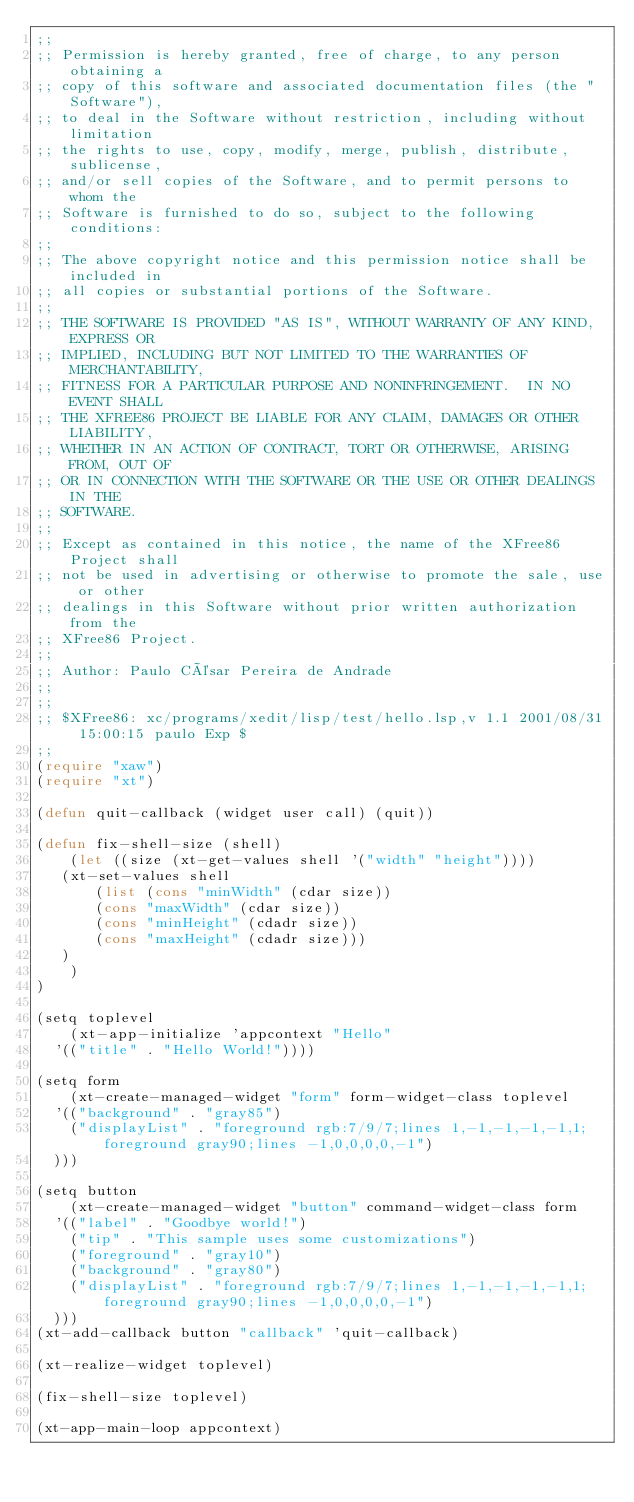Convert code to text. <code><loc_0><loc_0><loc_500><loc_500><_Lisp_>;;
;; Permission is hereby granted, free of charge, to any person obtaining a
;; copy of this software and associated documentation files (the "Software"),
;; to deal in the Software without restriction, including without limitation
;; the rights to use, copy, modify, merge, publish, distribute, sublicense,
;; and/or sell copies of the Software, and to permit persons to whom the
;; Software is furnished to do so, subject to the following conditions:
;;
;; The above copyright notice and this permission notice shall be included in
;; all copies or substantial portions of the Software.
;;  
;; THE SOFTWARE IS PROVIDED "AS IS", WITHOUT WARRANTY OF ANY KIND, EXPRESS OR
;; IMPLIED, INCLUDING BUT NOT LIMITED TO THE WARRANTIES OF MERCHANTABILITY,
;; FITNESS FOR A PARTICULAR PURPOSE AND NONINFRINGEMENT.  IN NO EVENT SHALL
;; THE XFREE86 PROJECT BE LIABLE FOR ANY CLAIM, DAMAGES OR OTHER LIABILITY,
;; WHETHER IN AN ACTION OF CONTRACT, TORT OR OTHERWISE, ARISING FROM, OUT OF
;; OR IN CONNECTION WITH THE SOFTWARE OR THE USE OR OTHER DEALINGS IN THE
;; SOFTWARE.
;;
;; Except as contained in this notice, the name of the XFree86 Project shall
;; not be used in advertising or otherwise to promote the sale, use or other
;; dealings in this Software without prior written authorization from the
;; XFree86 Project.
;;
;; Author: Paulo César Pereira de Andrade
;;
;;
;; $XFree86: xc/programs/xedit/lisp/test/hello.lsp,v 1.1 2001/08/31 15:00:15 paulo Exp $
;;
(require "xaw")
(require "xt")

(defun quit-callback (widget user call) (quit))

(defun fix-shell-size (shell)
    (let ((size (xt-get-values shell '("width" "height"))))
	 (xt-set-values shell
	     (list (cons "minWidth" (cdar size))
		   (cons "maxWidth" (cdar size))
		   (cons "minHeight" (cdadr size))
		   (cons "maxHeight" (cdadr size)))
	 )
    )
)

(setq toplevel
    (xt-app-initialize 'appcontext "Hello"
	'(("title" . "Hello World!"))))

(setq form
    (xt-create-managed-widget "form" form-widget-class toplevel
	'(("background" . "gray85")
	  ("displayList" . "foreground rgb:7/9/7;lines 1,-1,-1,-1,-1,1;foreground gray90;lines -1,0,0,0,0,-1")
	)))

(setq button
    (xt-create-managed-widget "button" command-widget-class form
	'(("label" . "Goodbye world!")
	  ("tip" . "This sample uses some customizations")
	  ("foreground" . "gray10")
	  ("background" . "gray80")
	  ("displayList" . "foreground rgb:7/9/7;lines 1,-1,-1,-1,-1,1;foreground gray90;lines -1,0,0,0,0,-1")
	)))
(xt-add-callback button "callback" 'quit-callback)

(xt-realize-widget toplevel)

(fix-shell-size toplevel)

(xt-app-main-loop appcontext)
</code> 